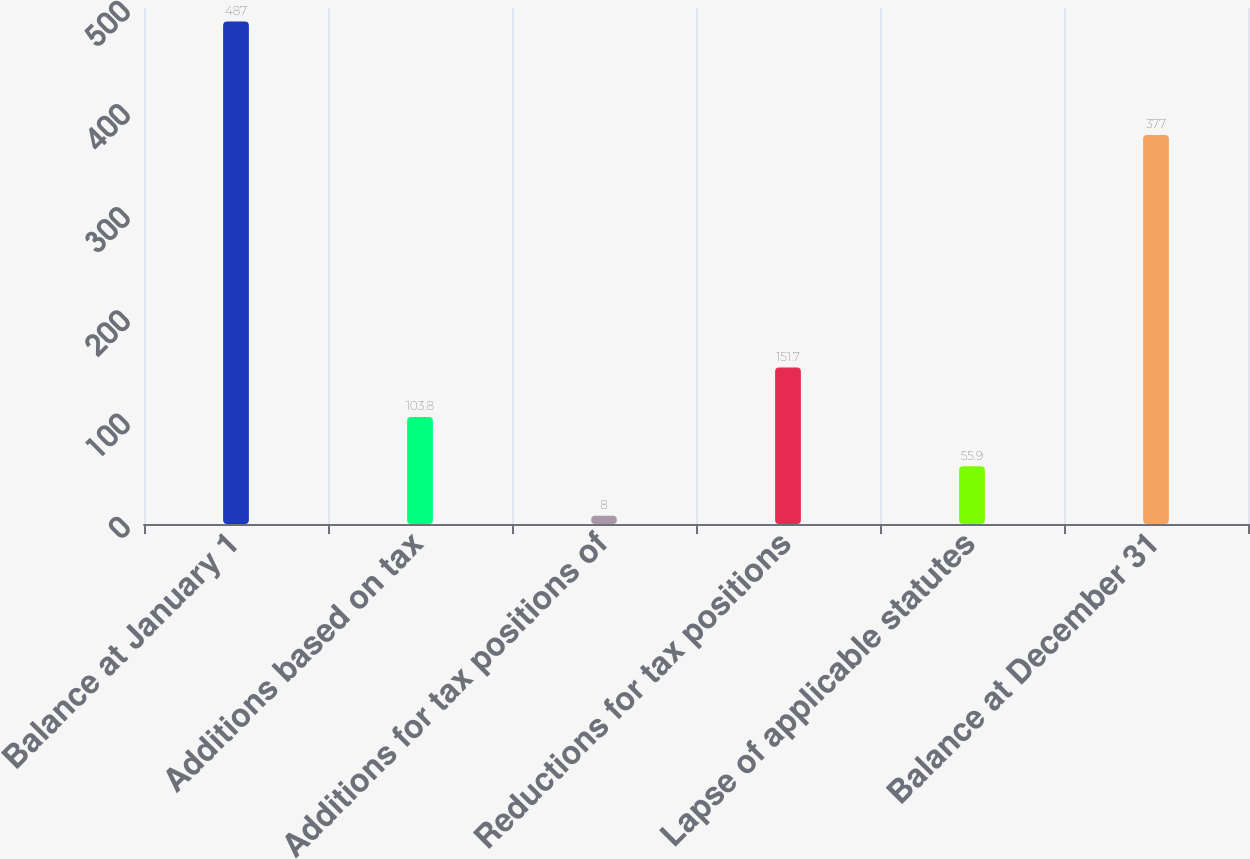Convert chart to OTSL. <chart><loc_0><loc_0><loc_500><loc_500><bar_chart><fcel>Balance at January 1<fcel>Additions based on tax<fcel>Additions for tax positions of<fcel>Reductions for tax positions<fcel>Lapse of applicable statutes<fcel>Balance at December 31<nl><fcel>487<fcel>103.8<fcel>8<fcel>151.7<fcel>55.9<fcel>377<nl></chart> 